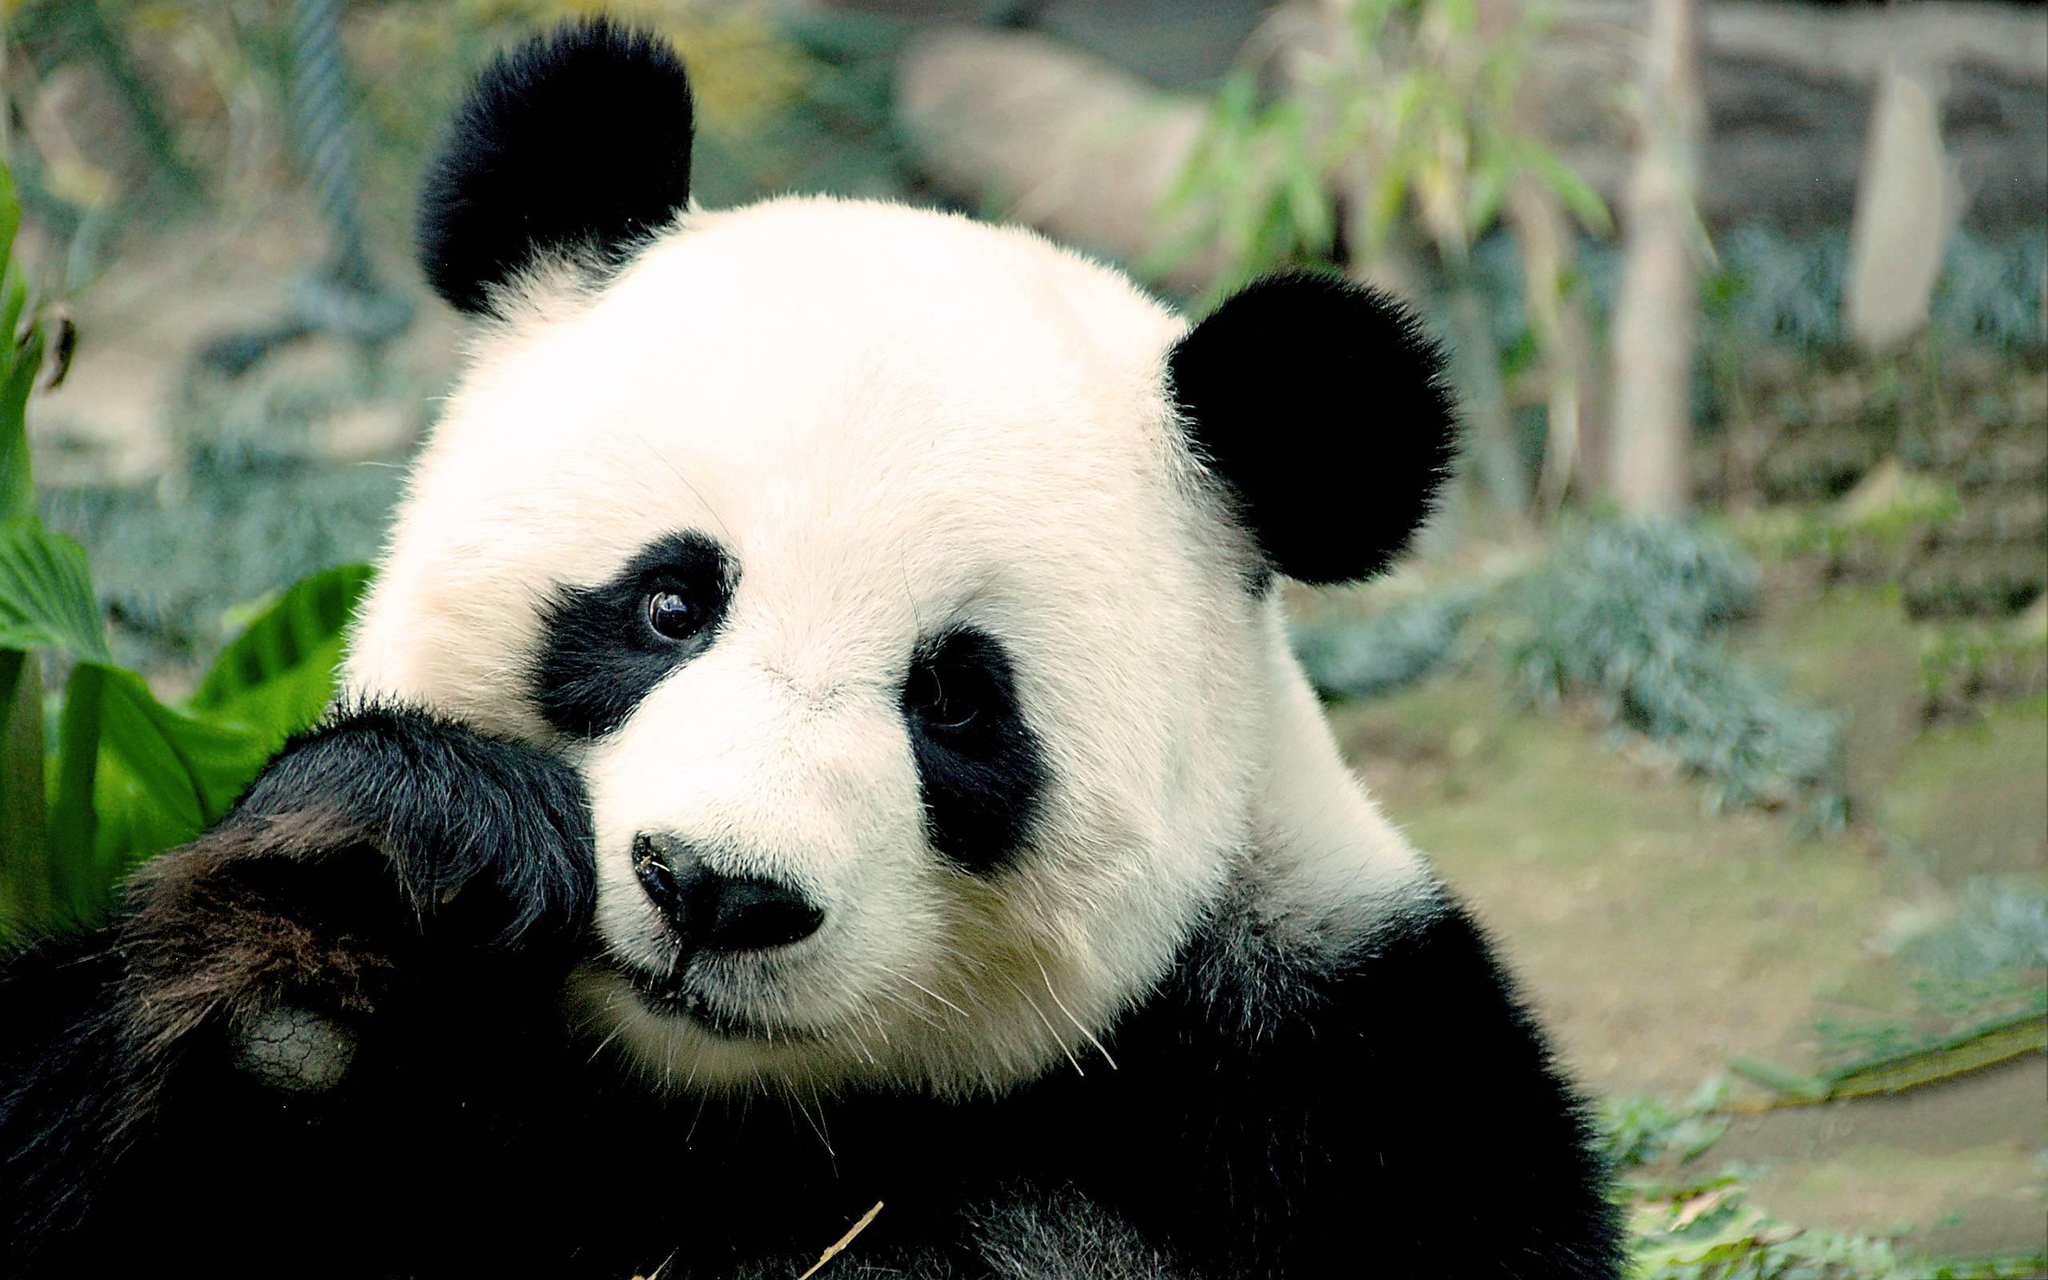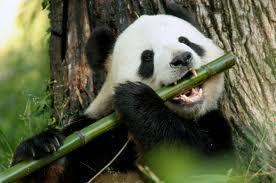The first image is the image on the left, the second image is the image on the right. Assess this claim about the two images: "One panda is munching a single leafless thick green stalk between his exposed upper and lower teeth.". Correct or not? Answer yes or no. Yes. The first image is the image on the left, the second image is the image on the right. For the images shown, is this caption "Each image shows a panda placing bamboo in its mouth." true? Answer yes or no. No. 